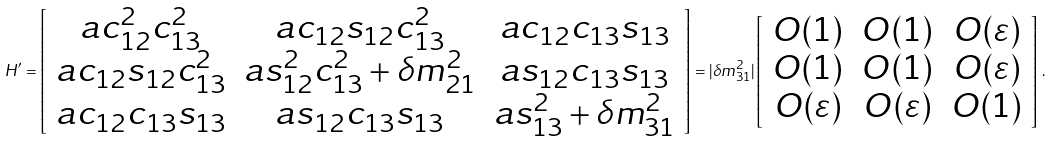Convert formula to latex. <formula><loc_0><loc_0><loc_500><loc_500>H ^ { \prime } = \left [ \begin{array} { c c c } a c _ { 1 2 } ^ { 2 } c _ { 1 3 } ^ { 2 } & a c _ { 1 2 } s _ { 1 2 } c _ { 1 3 } ^ { 2 } & a c _ { 1 2 } c _ { 1 3 } s _ { 1 3 } \\ a c _ { 1 2 } s _ { 1 2 } c _ { 1 3 } ^ { 2 } & a s _ { 1 2 } ^ { 2 } c _ { 1 3 } ^ { 2 } + \delta m ^ { 2 } _ { 2 1 } & a s _ { 1 2 } c _ { 1 3 } s _ { 1 3 } \\ a c _ { 1 2 } c _ { 1 3 } s _ { 1 3 } & a s _ { 1 2 } c _ { 1 3 } s _ { 1 3 } & a s _ { 1 3 } ^ { 2 } + \delta m ^ { 2 } _ { 3 1 } \end{array} \right ] = | \delta m ^ { 2 } _ { 3 1 } | \left [ \begin{array} { c c c } O ( 1 ) & O ( 1 ) & O ( \varepsilon ) \\ O ( 1 ) & O ( 1 ) & O ( \varepsilon ) \\ O ( \varepsilon ) & O ( \varepsilon ) & O ( 1 ) \\ \end{array} \right ] \, .</formula> 